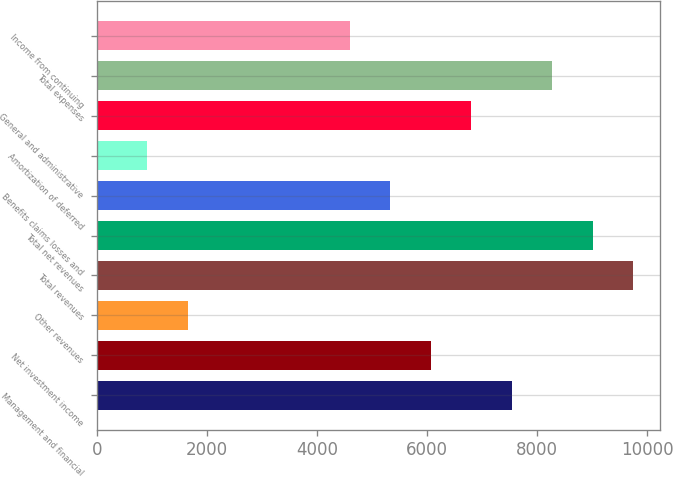Convert chart to OTSL. <chart><loc_0><loc_0><loc_500><loc_500><bar_chart><fcel>Management and financial<fcel>Net investment income<fcel>Other revenues<fcel>Total revenues<fcel>Total net revenues<fcel>Benefits claims losses and<fcel>Amortization of deferred<fcel>General and administrative<fcel>Total expenses<fcel>Income from continuing<nl><fcel>7538<fcel>6067.2<fcel>1654.8<fcel>9744.2<fcel>9008.8<fcel>5331.8<fcel>919.4<fcel>6802.6<fcel>8273.4<fcel>4596.4<nl></chart> 